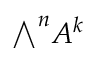<formula> <loc_0><loc_0><loc_500><loc_500>{ \bigwedge } ^ { n } A ^ { k }</formula> 